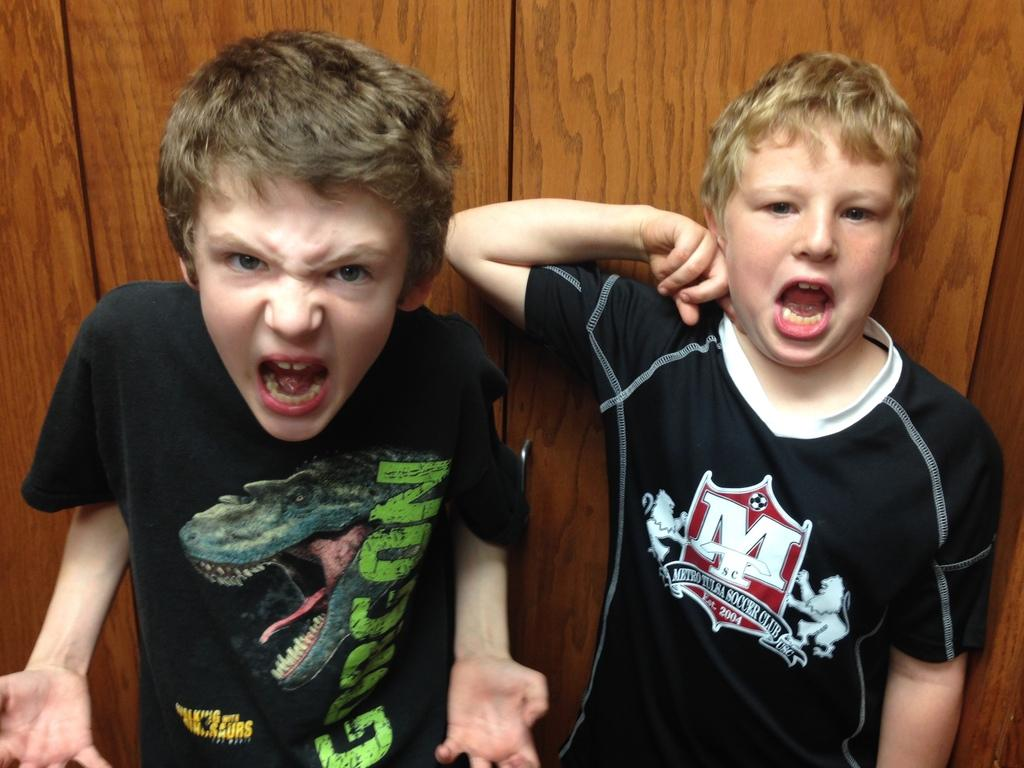How many boys are in the image? There are two boys in the image. What are the boys wearing? Both boys are wearing black t-shirts. What is the color of the backdrop in the image? There is a brown backdrop in the image. Where is the playground located in the image? There is no playground present in the image. What type of connection do the boys have in the image? The image does not provide information about any connection between the boys. 